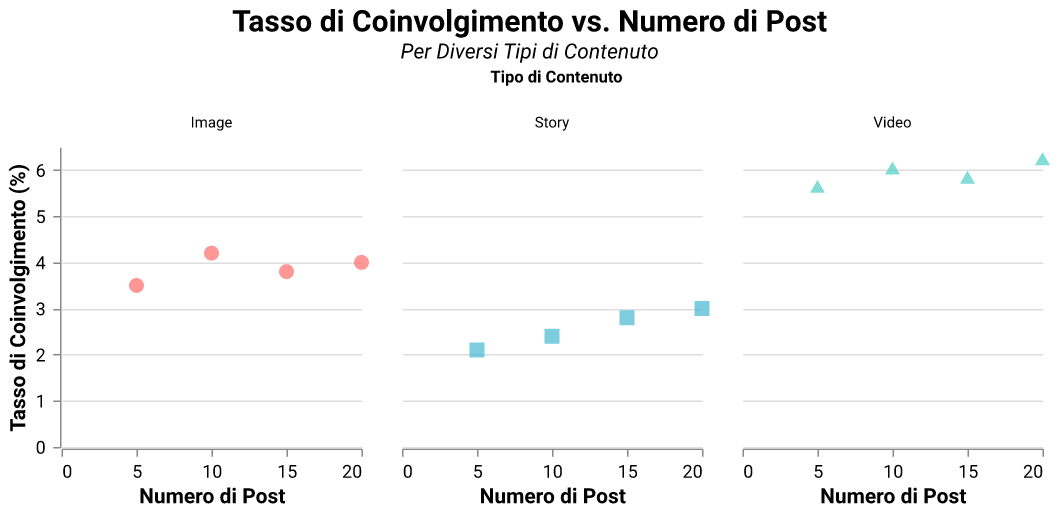What is the title of the figure? The title is displayed at the top of the figure and provides an overview of the content visualized.
Answer: Tasso di Coinvolgimento vs. Numero di Post How many different types of content are shown in the subplot? The figure divides the data into three different facets corresponding to the types of content. Each content type is labeled on top of each subplot.
Answer: 3 Which content type has the highest engagement rate for 20 posts? Check the '20 posts' mark on the x-axis for each content type and compare their y-values for engagement rates. The content type with the highest y-value is the answer.
Answer: Video Which content type shows the lowest engagement rate at 10 posts? Look at the '10 posts' mark on the x-axis for each content type and identify the one with the lowest y-value for engagement rates.
Answer: Story How does the engagement rate change with increasing number of posts for Image content? Observe the trend of the points in the 'Image' facet. Track how the y-values change as the x-values increase. The engagement rate somewhat fluctuates but stays around a certain range.
Answer: Fluctuates around 4 What's the overall trend in engagement rates for Video content as the number of posts increases? Check the pattern of the points in the 'Video' facet, noting how the engagement rate (y-value) changes as the number of posts (x-value) increases.
Answer: Increases What's the difference in engagement rate between 5 posts and 20 posts for Story content? Identify the engagement rates at 5 and 20 posts in the 'Story' facet, then calculate the difference.
Answer: 0.9 Comparing all content types, which has the most significant variability in engagement rates? Look at the range of engagement rates (y-values) within each content type in their respective facets. Determine which one has the largest difference between its minimum and maximum engagement rates.
Answer: Video What shape and color correspond to Video content on the plot? Observe the legend or pattern in the plot and identify the shape and color used for Video data points.
Answer: Triangle, turquoise What could be a possible reason for different trends in engagement rates among different content types? Compare the trends observed in each content type. Consider factors like how viewers might interact differently with images, videos, and stories. This requires understanding viewing habits and preferences for each type of content.
Answer: Viewer interaction varies by content type 